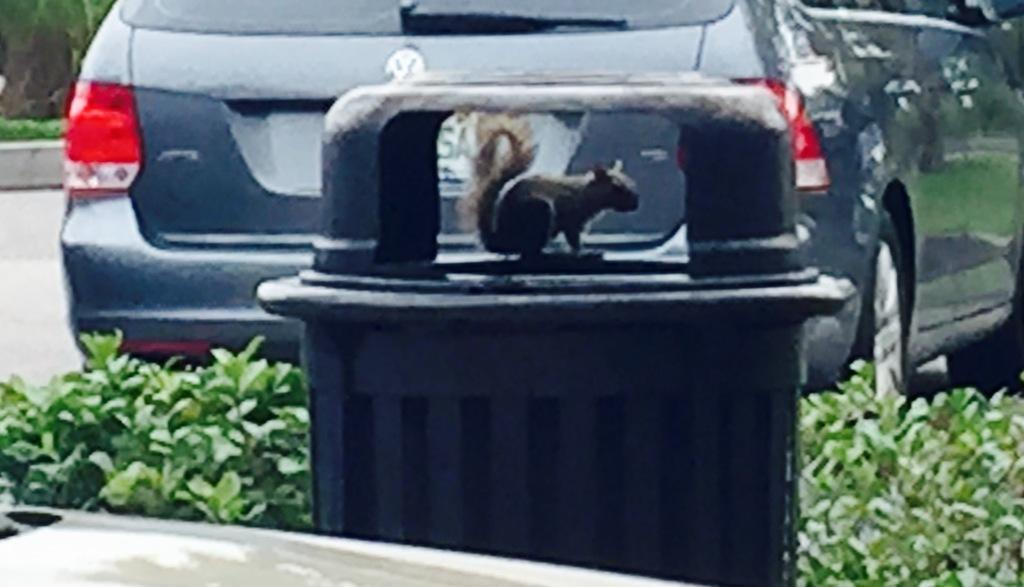What object is present in the image that is used for waste disposal? There is a dustbin in the image. What animal can be seen on top of the dustbin? A squirrel is on top of the dustbin. What type of vegetation is visible behind the dustbin? There are plants behind the dustbin. What type of vehicle is in front of the plants? There is a car in front of the plants. Can you see any writing on the squirrel in the image? There is no writing visible on the squirrel in the image. How does the car increase its speed in the image? The car is stationary in the image, so there is no motion or increase in speed. 